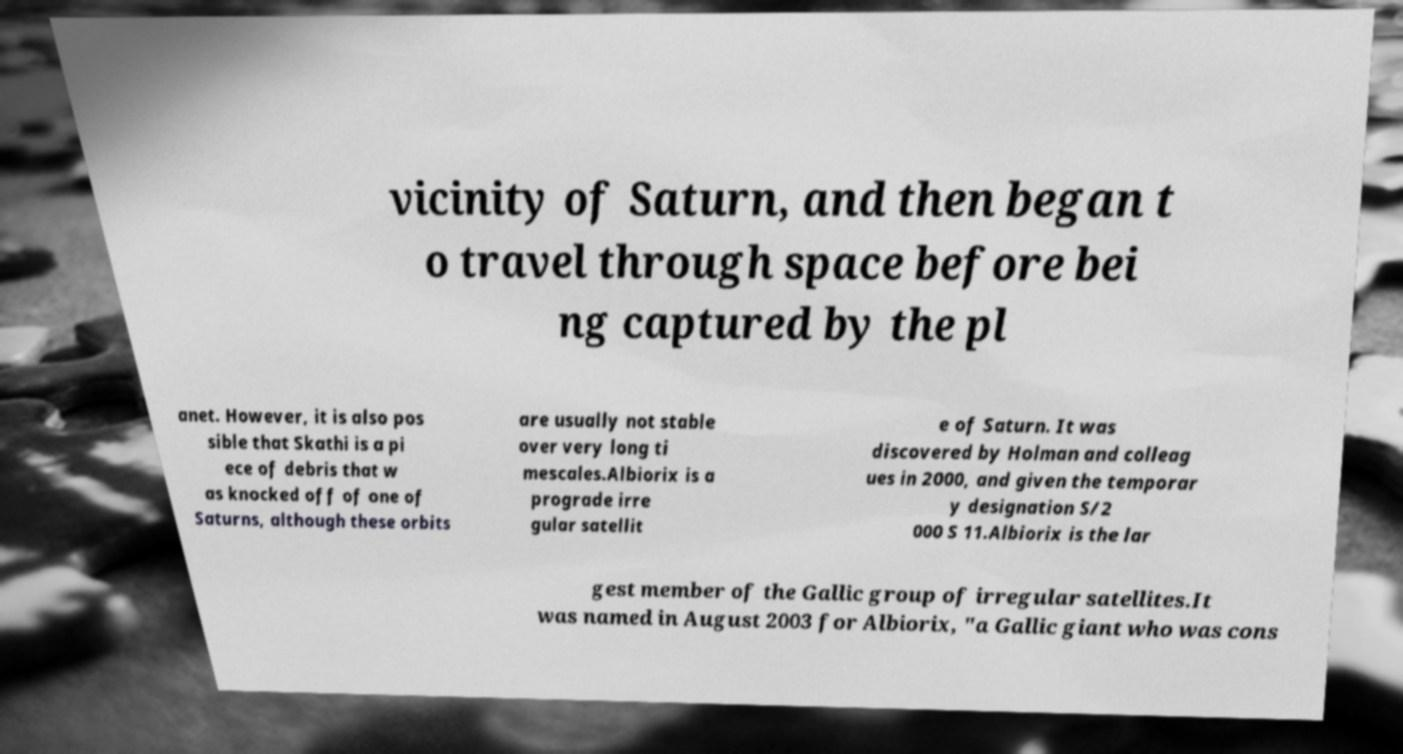Could you extract and type out the text from this image? vicinity of Saturn, and then began t o travel through space before bei ng captured by the pl anet. However, it is also pos sible that Skathi is a pi ece of debris that w as knocked off of one of Saturns, although these orbits are usually not stable over very long ti mescales.Albiorix is a prograde irre gular satellit e of Saturn. It was discovered by Holman and colleag ues in 2000, and given the temporar y designation S/2 000 S 11.Albiorix is the lar gest member of the Gallic group of irregular satellites.It was named in August 2003 for Albiorix, "a Gallic giant who was cons 